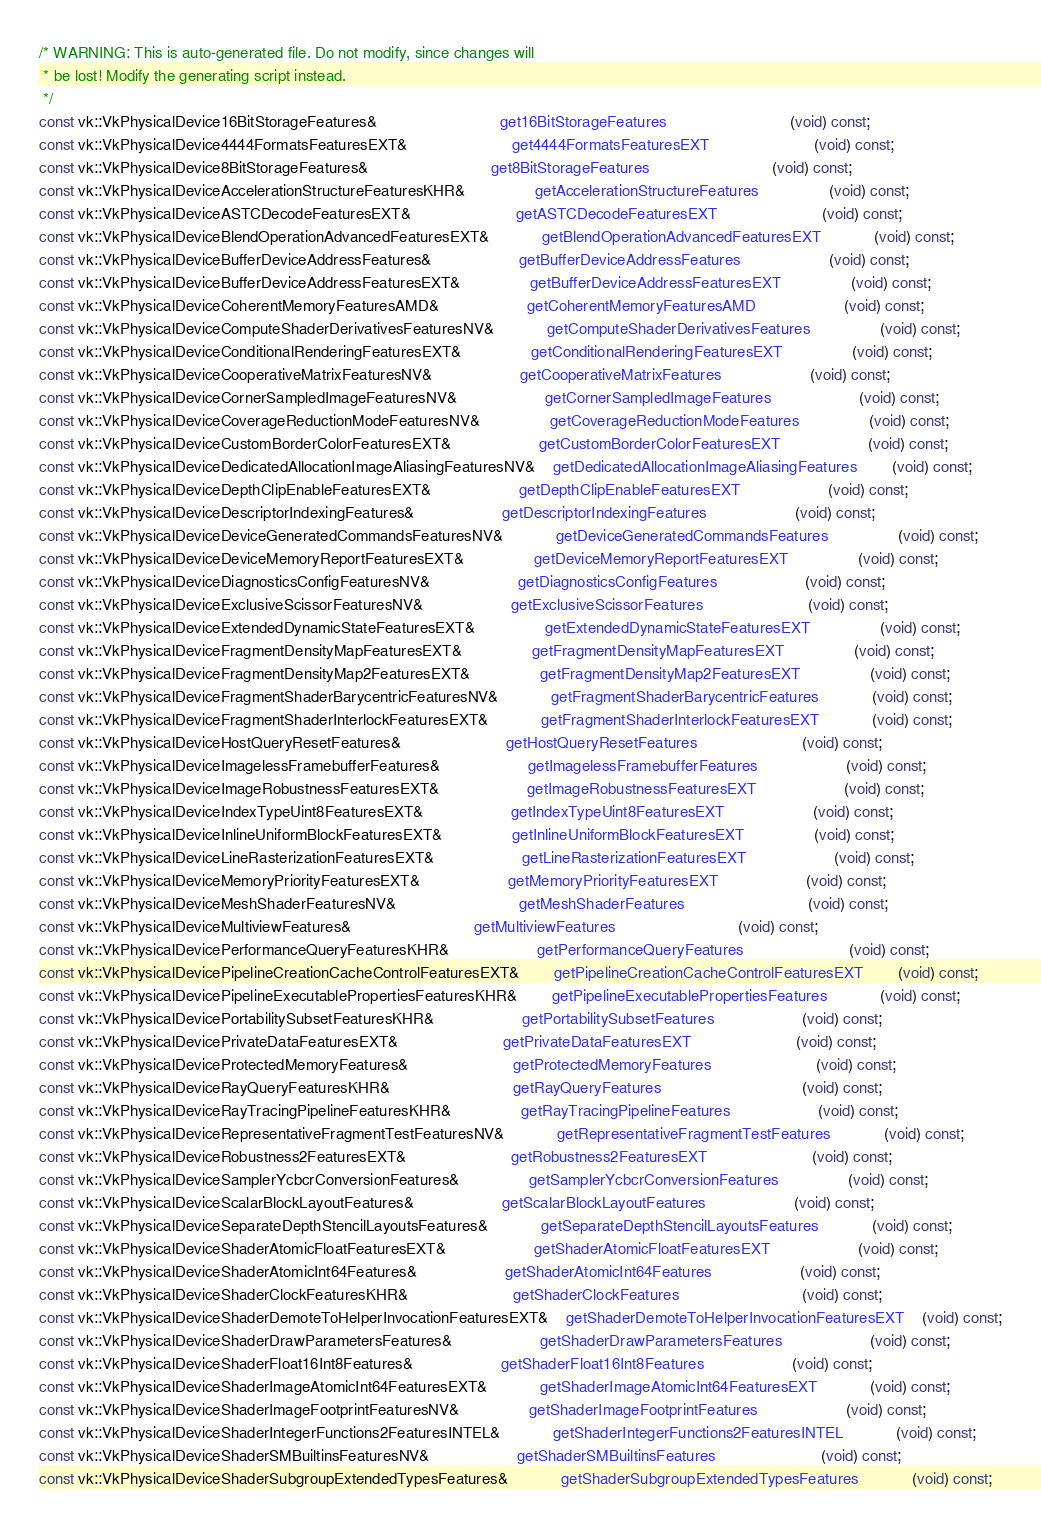Convert code to text. <code><loc_0><loc_0><loc_500><loc_500><_C++_>/* WARNING: This is auto-generated file. Do not modify, since changes will
 * be lost! Modify the generating script instead.
 */
const vk::VkPhysicalDevice16BitStorageFeatures&							get16BitStorageFeatures							(void) const;
const vk::VkPhysicalDevice4444FormatsFeaturesEXT&						get4444FormatsFeaturesEXT						(void) const;
const vk::VkPhysicalDevice8BitStorageFeatures&							get8BitStorageFeatures							(void) const;
const vk::VkPhysicalDeviceAccelerationStructureFeaturesKHR&				getAccelerationStructureFeatures				(void) const;
const vk::VkPhysicalDeviceASTCDecodeFeaturesEXT&						getASTCDecodeFeaturesEXT						(void) const;
const vk::VkPhysicalDeviceBlendOperationAdvancedFeaturesEXT&			getBlendOperationAdvancedFeaturesEXT			(void) const;
const vk::VkPhysicalDeviceBufferDeviceAddressFeatures&					getBufferDeviceAddressFeatures					(void) const;
const vk::VkPhysicalDeviceBufferDeviceAddressFeaturesEXT&				getBufferDeviceAddressFeaturesEXT				(void) const;
const vk::VkPhysicalDeviceCoherentMemoryFeaturesAMD&					getCoherentMemoryFeaturesAMD					(void) const;
const vk::VkPhysicalDeviceComputeShaderDerivativesFeaturesNV&			getComputeShaderDerivativesFeatures				(void) const;
const vk::VkPhysicalDeviceConditionalRenderingFeaturesEXT&				getConditionalRenderingFeaturesEXT				(void) const;
const vk::VkPhysicalDeviceCooperativeMatrixFeaturesNV&					getCooperativeMatrixFeatures					(void) const;
const vk::VkPhysicalDeviceCornerSampledImageFeaturesNV&					getCornerSampledImageFeatures					(void) const;
const vk::VkPhysicalDeviceCoverageReductionModeFeaturesNV&				getCoverageReductionModeFeatures				(void) const;
const vk::VkPhysicalDeviceCustomBorderColorFeaturesEXT&					getCustomBorderColorFeaturesEXT					(void) const;
const vk::VkPhysicalDeviceDedicatedAllocationImageAliasingFeaturesNV&	getDedicatedAllocationImageAliasingFeatures		(void) const;
const vk::VkPhysicalDeviceDepthClipEnableFeaturesEXT&					getDepthClipEnableFeaturesEXT					(void) const;
const vk::VkPhysicalDeviceDescriptorIndexingFeatures&					getDescriptorIndexingFeatures					(void) const;
const vk::VkPhysicalDeviceDeviceGeneratedCommandsFeaturesNV&			getDeviceGeneratedCommandsFeatures				(void) const;
const vk::VkPhysicalDeviceDeviceMemoryReportFeaturesEXT&				getDeviceMemoryReportFeaturesEXT				(void) const;
const vk::VkPhysicalDeviceDiagnosticsConfigFeaturesNV&					getDiagnosticsConfigFeatures					(void) const;
const vk::VkPhysicalDeviceExclusiveScissorFeaturesNV&					getExclusiveScissorFeatures						(void) const;
const vk::VkPhysicalDeviceExtendedDynamicStateFeaturesEXT&				getExtendedDynamicStateFeaturesEXT				(void) const;
const vk::VkPhysicalDeviceFragmentDensityMapFeaturesEXT&				getFragmentDensityMapFeaturesEXT				(void) const;
const vk::VkPhysicalDeviceFragmentDensityMap2FeaturesEXT&				getFragmentDensityMap2FeaturesEXT				(void) const;
const vk::VkPhysicalDeviceFragmentShaderBarycentricFeaturesNV&			getFragmentShaderBarycentricFeatures			(void) const;
const vk::VkPhysicalDeviceFragmentShaderInterlockFeaturesEXT&			getFragmentShaderInterlockFeaturesEXT			(void) const;
const vk::VkPhysicalDeviceHostQueryResetFeatures&						getHostQueryResetFeatures						(void) const;
const vk::VkPhysicalDeviceImagelessFramebufferFeatures&					getImagelessFramebufferFeatures					(void) const;
const vk::VkPhysicalDeviceImageRobustnessFeaturesEXT&					getImageRobustnessFeaturesEXT					(void) const;
const vk::VkPhysicalDeviceIndexTypeUint8FeaturesEXT&					getIndexTypeUint8FeaturesEXT					(void) const;
const vk::VkPhysicalDeviceInlineUniformBlockFeaturesEXT&				getInlineUniformBlockFeaturesEXT				(void) const;
const vk::VkPhysicalDeviceLineRasterizationFeaturesEXT&					getLineRasterizationFeaturesEXT					(void) const;
const vk::VkPhysicalDeviceMemoryPriorityFeaturesEXT&					getMemoryPriorityFeaturesEXT					(void) const;
const vk::VkPhysicalDeviceMeshShaderFeaturesNV&							getMeshShaderFeatures							(void) const;
const vk::VkPhysicalDeviceMultiviewFeatures&							getMultiviewFeatures							(void) const;
const vk::VkPhysicalDevicePerformanceQueryFeaturesKHR&					getPerformanceQueryFeatures						(void) const;
const vk::VkPhysicalDevicePipelineCreationCacheControlFeaturesEXT&		getPipelineCreationCacheControlFeaturesEXT		(void) const;
const vk::VkPhysicalDevicePipelineExecutablePropertiesFeaturesKHR&		getPipelineExecutablePropertiesFeatures			(void) const;
const vk::VkPhysicalDevicePortabilitySubsetFeaturesKHR&					getPortabilitySubsetFeatures					(void) const;
const vk::VkPhysicalDevicePrivateDataFeaturesEXT&						getPrivateDataFeaturesEXT						(void) const;
const vk::VkPhysicalDeviceProtectedMemoryFeatures&						getProtectedMemoryFeatures						(void) const;
const vk::VkPhysicalDeviceRayQueryFeaturesKHR&							getRayQueryFeatures								(void) const;
const vk::VkPhysicalDeviceRayTracingPipelineFeaturesKHR&				getRayTracingPipelineFeatures					(void) const;
const vk::VkPhysicalDeviceRepresentativeFragmentTestFeaturesNV&			getRepresentativeFragmentTestFeatures			(void) const;
const vk::VkPhysicalDeviceRobustness2FeaturesEXT&						getRobustness2FeaturesEXT						(void) const;
const vk::VkPhysicalDeviceSamplerYcbcrConversionFeatures&				getSamplerYcbcrConversionFeatures				(void) const;
const vk::VkPhysicalDeviceScalarBlockLayoutFeatures&					getScalarBlockLayoutFeatures					(void) const;
const vk::VkPhysicalDeviceSeparateDepthStencilLayoutsFeatures&			getSeparateDepthStencilLayoutsFeatures			(void) const;
const vk::VkPhysicalDeviceShaderAtomicFloatFeaturesEXT&					getShaderAtomicFloatFeaturesEXT					(void) const;
const vk::VkPhysicalDeviceShaderAtomicInt64Features&					getShaderAtomicInt64Features					(void) const;
const vk::VkPhysicalDeviceShaderClockFeaturesKHR&						getShaderClockFeatures							(void) const;
const vk::VkPhysicalDeviceShaderDemoteToHelperInvocationFeaturesEXT&	getShaderDemoteToHelperInvocationFeaturesEXT	(void) const;
const vk::VkPhysicalDeviceShaderDrawParametersFeatures&					getShaderDrawParametersFeatures					(void) const;
const vk::VkPhysicalDeviceShaderFloat16Int8Features&					getShaderFloat16Int8Features					(void) const;
const vk::VkPhysicalDeviceShaderImageAtomicInt64FeaturesEXT&			getShaderImageAtomicInt64FeaturesEXT			(void) const;
const vk::VkPhysicalDeviceShaderImageFootprintFeaturesNV&				getShaderImageFootprintFeatures					(void) const;
const vk::VkPhysicalDeviceShaderIntegerFunctions2FeaturesINTEL&			getShaderIntegerFunctions2FeaturesINTEL			(void) const;
const vk::VkPhysicalDeviceShaderSMBuiltinsFeaturesNV&					getShaderSMBuiltinsFeatures						(void) const;
const vk::VkPhysicalDeviceShaderSubgroupExtendedTypesFeatures&			getShaderSubgroupExtendedTypesFeatures			(void) const;</code> 